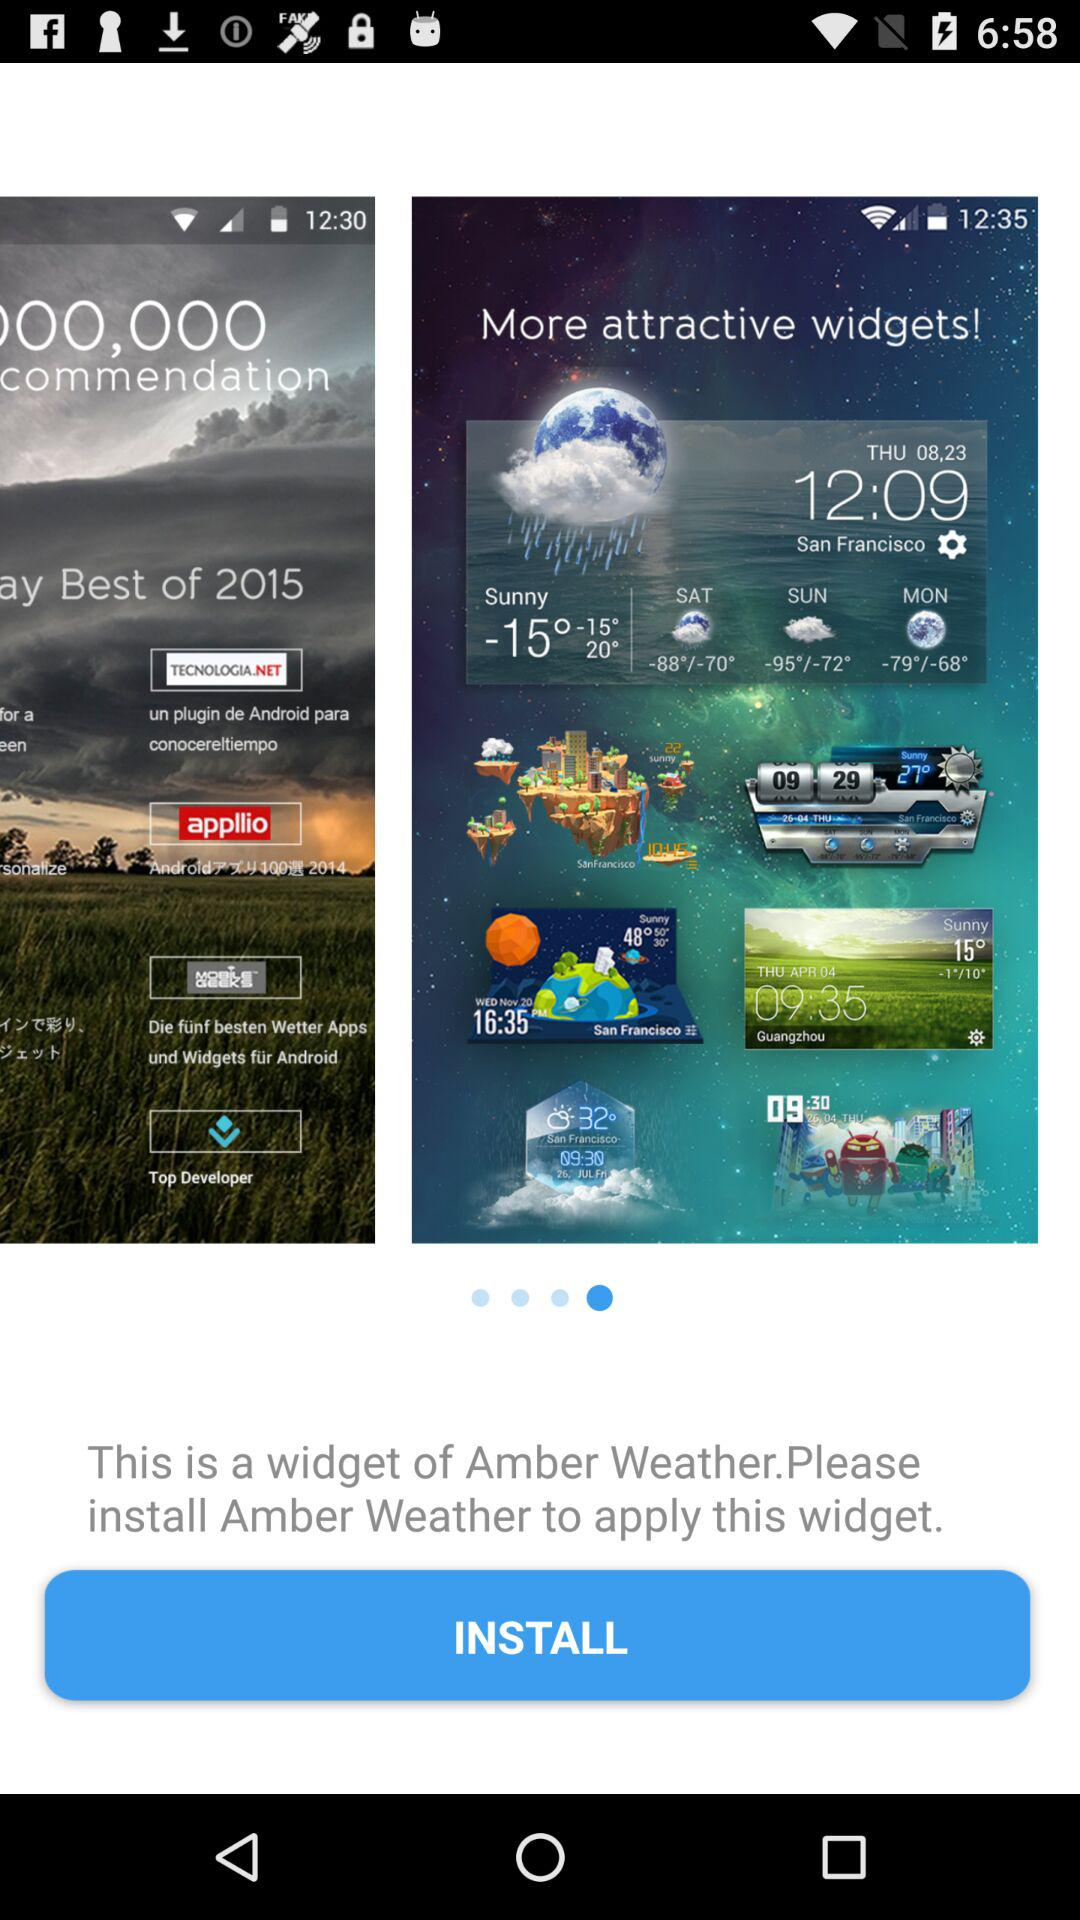Which day was rainy?
When the provided information is insufficient, respond with <no answer>. <no answer> 